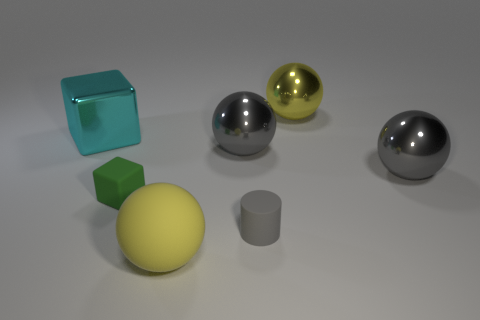Subtract 1 spheres. How many spheres are left? 3 Subtract all cyan balls. Subtract all purple cubes. How many balls are left? 4 Add 2 tiny cylinders. How many objects exist? 9 Subtract all cylinders. How many objects are left? 6 Add 5 small matte cylinders. How many small matte cylinders are left? 6 Add 7 blue shiny things. How many blue shiny things exist? 7 Subtract 0 red blocks. How many objects are left? 7 Subtract all cylinders. Subtract all big yellow objects. How many objects are left? 4 